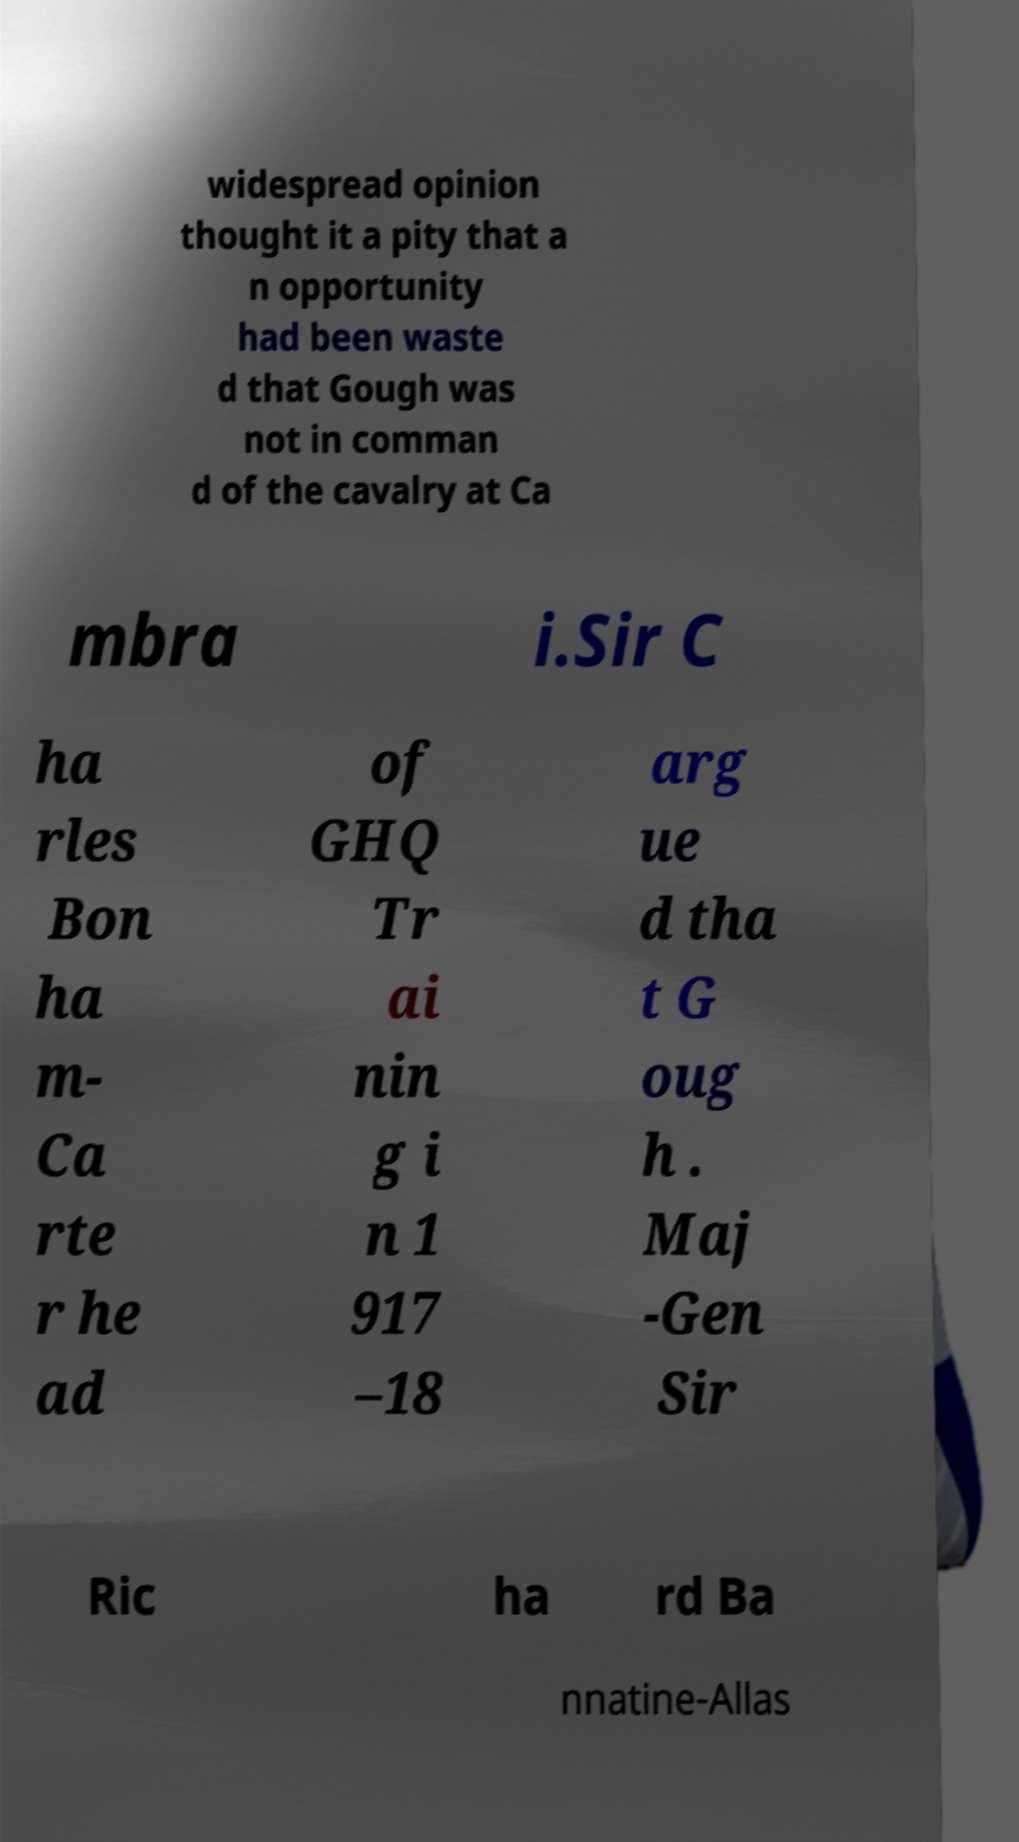I need the written content from this picture converted into text. Can you do that? widespread opinion thought it a pity that a n opportunity had been waste d that Gough was not in comman d of the cavalry at Ca mbra i.Sir C ha rles Bon ha m- Ca rte r he ad of GHQ Tr ai nin g i n 1 917 –18 arg ue d tha t G oug h . Maj -Gen Sir Ric ha rd Ba nnatine-Allas 